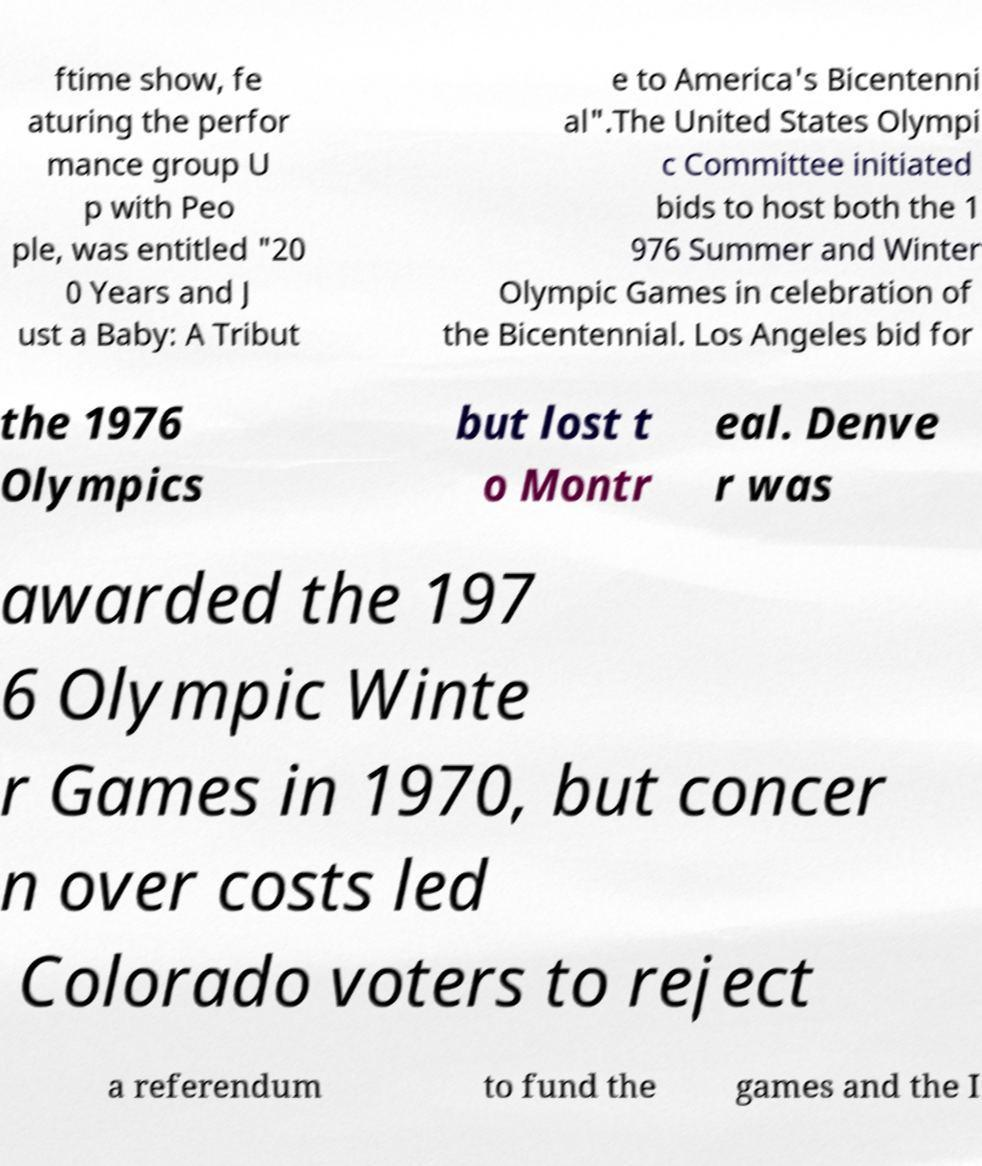What messages or text are displayed in this image? I need them in a readable, typed format. ftime show, fe aturing the perfor mance group U p with Peo ple, was entitled "20 0 Years and J ust a Baby: A Tribut e to America's Bicentenni al".The United States Olympi c Committee initiated bids to host both the 1 976 Summer and Winter Olympic Games in celebration of the Bicentennial. Los Angeles bid for the 1976 Olympics but lost t o Montr eal. Denve r was awarded the 197 6 Olympic Winte r Games in 1970, but concer n over costs led Colorado voters to reject a referendum to fund the games and the I 